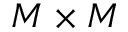Convert formula to latex. <formula><loc_0><loc_0><loc_500><loc_500>M \times M</formula> 